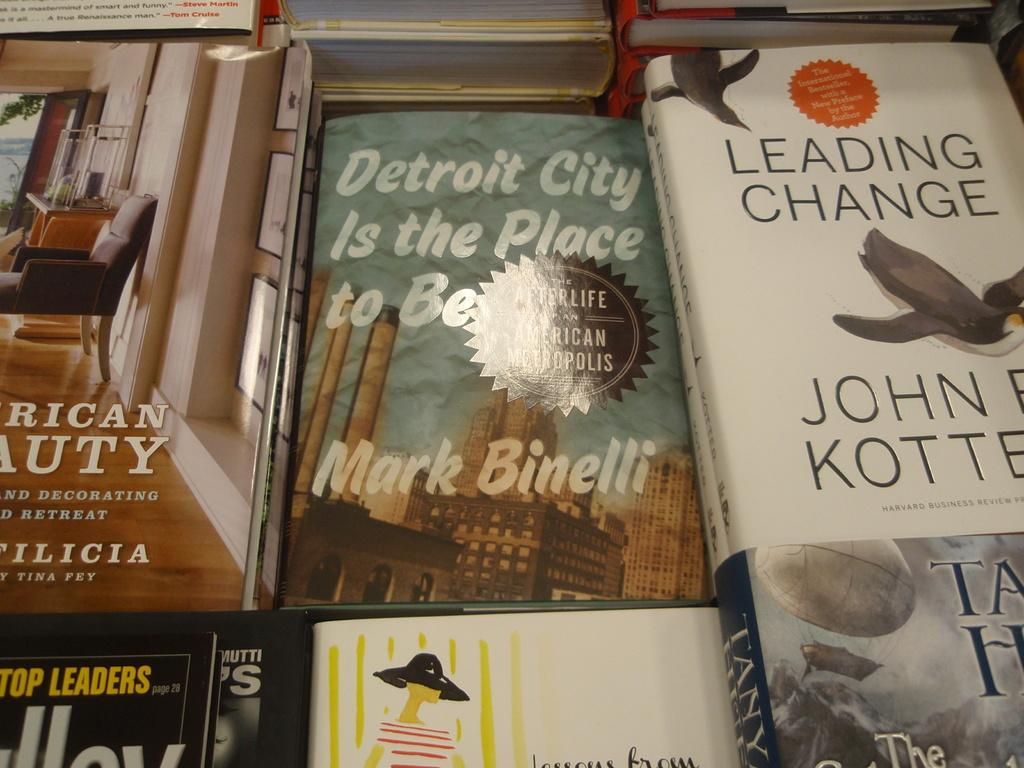Provide a one-sentence caption for the provided image. a table full of books with one of them titled 'detroit city is the place to be'. 